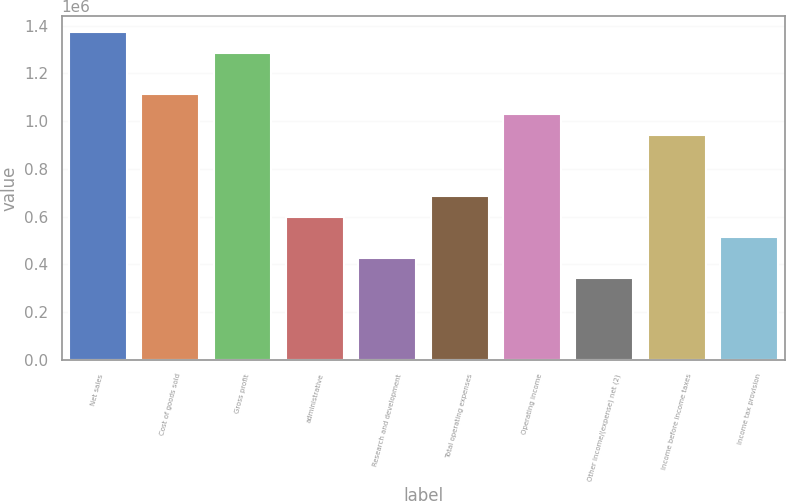Convert chart. <chart><loc_0><loc_0><loc_500><loc_500><bar_chart><fcel>Net sales<fcel>Cost of goods sold<fcel>Gross profit<fcel>administrative<fcel>Research and development<fcel>Total operating expenses<fcel>Operating income<fcel>Other income/(expense) net (2)<fcel>Income before income taxes<fcel>Income tax provision<nl><fcel>1.37111e+06<fcel>1.11403e+06<fcel>1.28542e+06<fcel>599862<fcel>428473<fcel>685556<fcel>1.02833e+06<fcel>342778<fcel>942639<fcel>514167<nl></chart> 